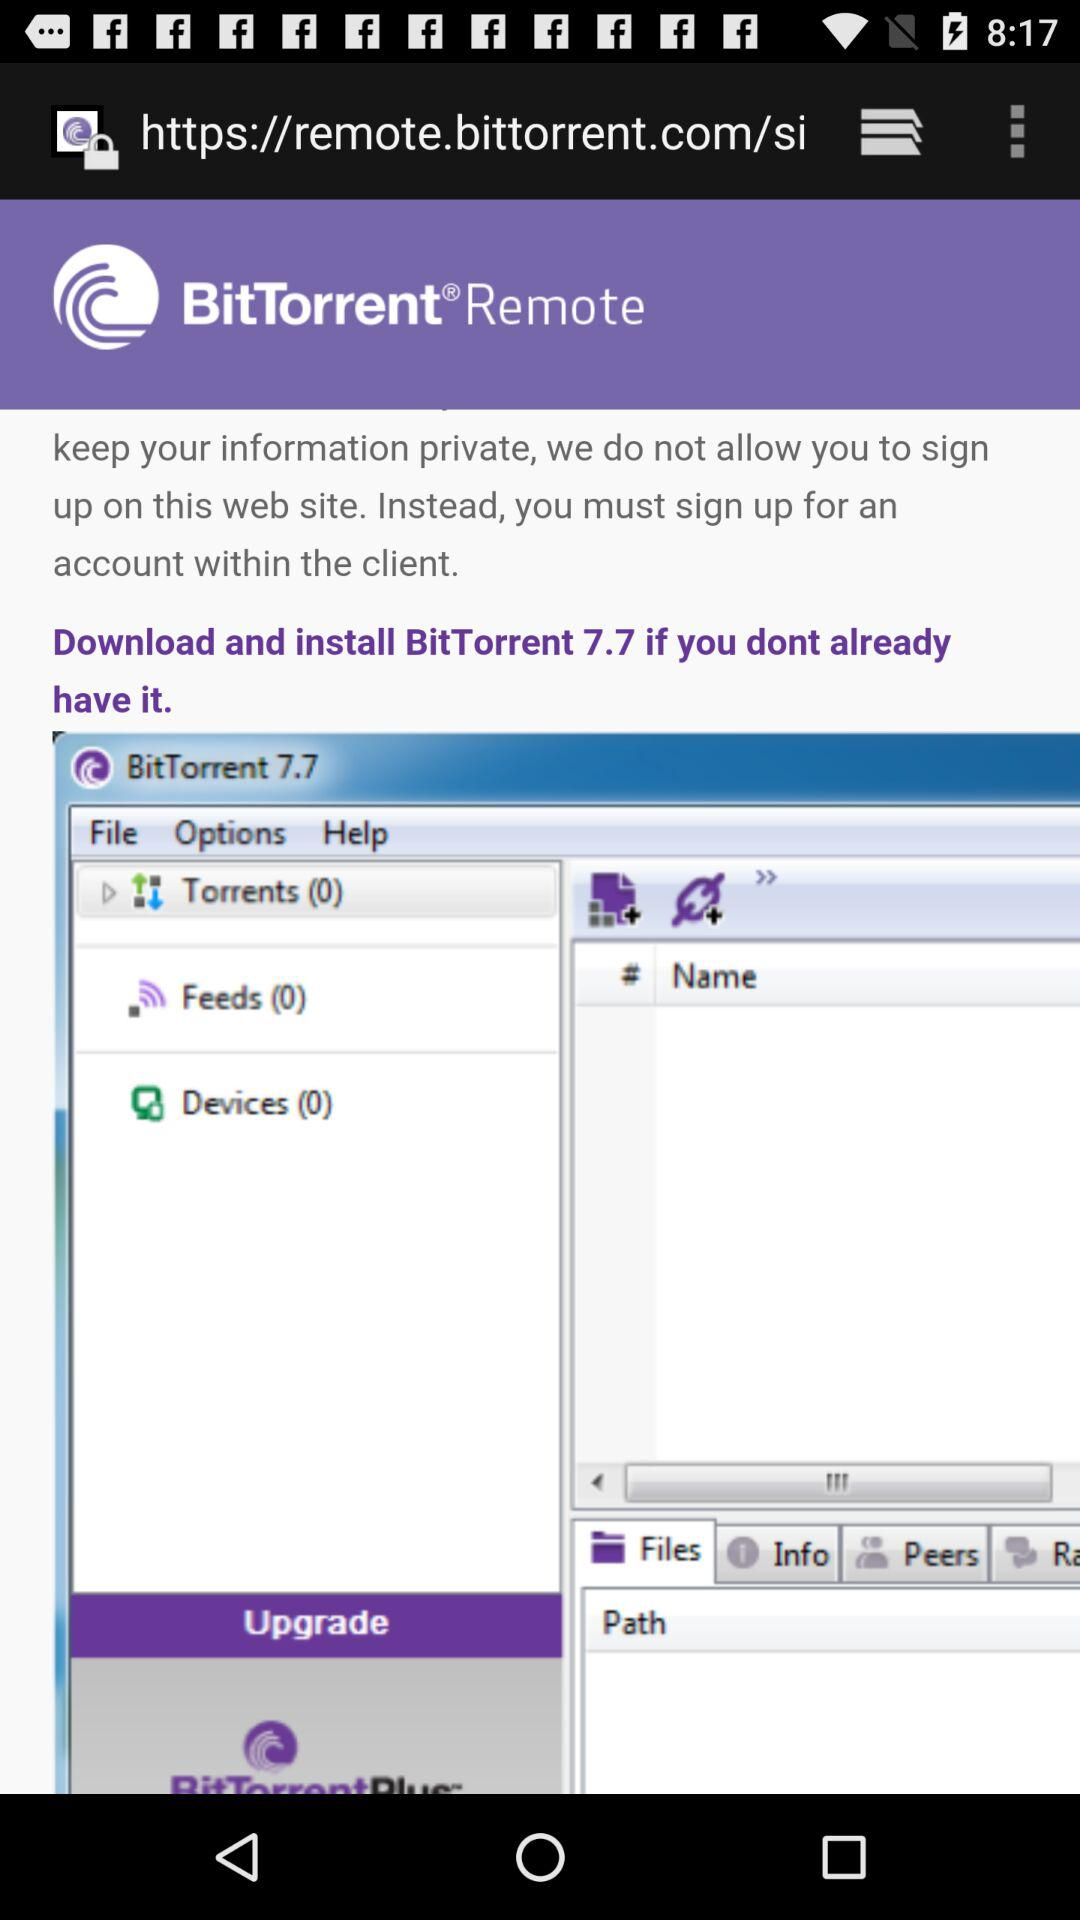How many devices are there? There are 0 devices. 